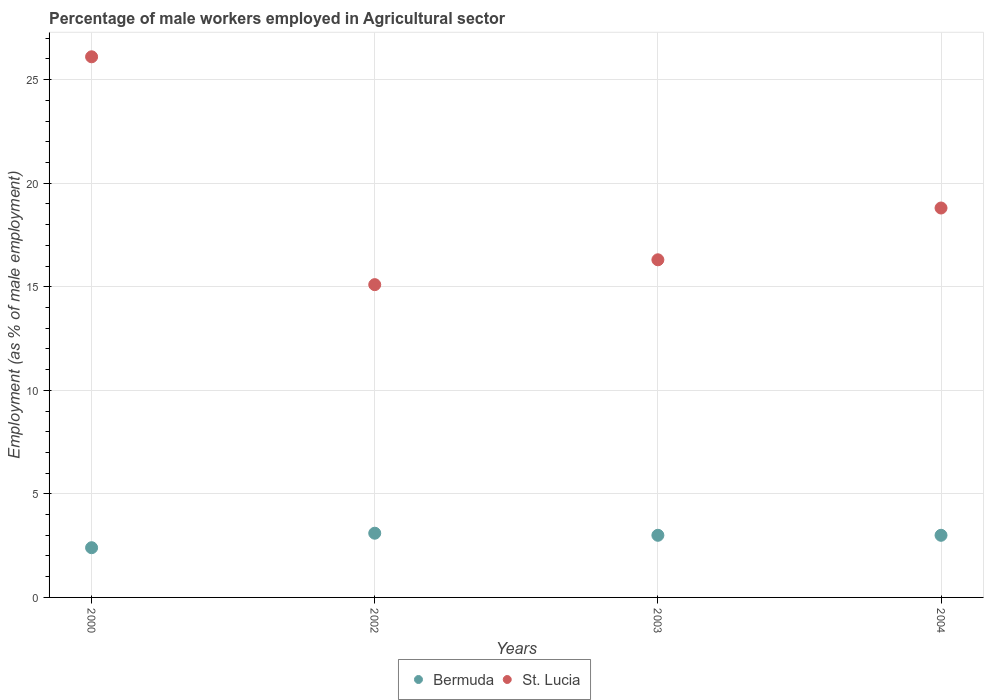How many different coloured dotlines are there?
Offer a terse response. 2. Is the number of dotlines equal to the number of legend labels?
Provide a short and direct response. Yes. What is the percentage of male workers employed in Agricultural sector in Bermuda in 2000?
Make the answer very short. 2.4. Across all years, what is the maximum percentage of male workers employed in Agricultural sector in St. Lucia?
Ensure brevity in your answer.  26.1. Across all years, what is the minimum percentage of male workers employed in Agricultural sector in Bermuda?
Your response must be concise. 2.4. What is the total percentage of male workers employed in Agricultural sector in St. Lucia in the graph?
Make the answer very short. 76.3. What is the difference between the percentage of male workers employed in Agricultural sector in Bermuda in 2000 and that in 2004?
Keep it short and to the point. -0.6. What is the difference between the percentage of male workers employed in Agricultural sector in St. Lucia in 2002 and the percentage of male workers employed in Agricultural sector in Bermuda in 2003?
Your response must be concise. 12.1. What is the average percentage of male workers employed in Agricultural sector in St. Lucia per year?
Your response must be concise. 19.07. In the year 2003, what is the difference between the percentage of male workers employed in Agricultural sector in St. Lucia and percentage of male workers employed in Agricultural sector in Bermuda?
Your answer should be very brief. 13.3. In how many years, is the percentage of male workers employed in Agricultural sector in St. Lucia greater than 13 %?
Provide a short and direct response. 4. What is the ratio of the percentage of male workers employed in Agricultural sector in St. Lucia in 2002 to that in 2004?
Provide a succinct answer. 0.8. Is the difference between the percentage of male workers employed in Agricultural sector in St. Lucia in 2002 and 2004 greater than the difference between the percentage of male workers employed in Agricultural sector in Bermuda in 2002 and 2004?
Keep it short and to the point. No. What is the difference between the highest and the second highest percentage of male workers employed in Agricultural sector in St. Lucia?
Provide a short and direct response. 7.3. What is the difference between the highest and the lowest percentage of male workers employed in Agricultural sector in St. Lucia?
Offer a very short reply. 11. In how many years, is the percentage of male workers employed in Agricultural sector in Bermuda greater than the average percentage of male workers employed in Agricultural sector in Bermuda taken over all years?
Provide a short and direct response. 3. Does the percentage of male workers employed in Agricultural sector in St. Lucia monotonically increase over the years?
Provide a short and direct response. No. Does the graph contain any zero values?
Offer a very short reply. No. Does the graph contain grids?
Your answer should be compact. Yes. Where does the legend appear in the graph?
Keep it short and to the point. Bottom center. How many legend labels are there?
Give a very brief answer. 2. What is the title of the graph?
Provide a succinct answer. Percentage of male workers employed in Agricultural sector. Does "Niger" appear as one of the legend labels in the graph?
Ensure brevity in your answer.  No. What is the label or title of the X-axis?
Ensure brevity in your answer.  Years. What is the label or title of the Y-axis?
Ensure brevity in your answer.  Employment (as % of male employment). What is the Employment (as % of male employment) of Bermuda in 2000?
Ensure brevity in your answer.  2.4. What is the Employment (as % of male employment) of St. Lucia in 2000?
Provide a succinct answer. 26.1. What is the Employment (as % of male employment) of Bermuda in 2002?
Ensure brevity in your answer.  3.1. What is the Employment (as % of male employment) of St. Lucia in 2002?
Offer a very short reply. 15.1. What is the Employment (as % of male employment) in St. Lucia in 2003?
Provide a short and direct response. 16.3. What is the Employment (as % of male employment) of St. Lucia in 2004?
Keep it short and to the point. 18.8. Across all years, what is the maximum Employment (as % of male employment) in Bermuda?
Offer a very short reply. 3.1. Across all years, what is the maximum Employment (as % of male employment) of St. Lucia?
Give a very brief answer. 26.1. Across all years, what is the minimum Employment (as % of male employment) of Bermuda?
Ensure brevity in your answer.  2.4. Across all years, what is the minimum Employment (as % of male employment) of St. Lucia?
Give a very brief answer. 15.1. What is the total Employment (as % of male employment) in Bermuda in the graph?
Ensure brevity in your answer.  11.5. What is the total Employment (as % of male employment) in St. Lucia in the graph?
Ensure brevity in your answer.  76.3. What is the difference between the Employment (as % of male employment) of St. Lucia in 2000 and that in 2002?
Offer a very short reply. 11. What is the difference between the Employment (as % of male employment) in Bermuda in 2000 and that in 2003?
Your response must be concise. -0.6. What is the difference between the Employment (as % of male employment) in Bermuda in 2000 and that in 2004?
Offer a very short reply. -0.6. What is the difference between the Employment (as % of male employment) in St. Lucia in 2002 and that in 2003?
Offer a terse response. -1.2. What is the difference between the Employment (as % of male employment) in Bermuda in 2002 and that in 2004?
Keep it short and to the point. 0.1. What is the difference between the Employment (as % of male employment) of Bermuda in 2000 and the Employment (as % of male employment) of St. Lucia in 2003?
Offer a terse response. -13.9. What is the difference between the Employment (as % of male employment) in Bermuda in 2000 and the Employment (as % of male employment) in St. Lucia in 2004?
Provide a short and direct response. -16.4. What is the difference between the Employment (as % of male employment) of Bermuda in 2002 and the Employment (as % of male employment) of St. Lucia in 2003?
Provide a succinct answer. -13.2. What is the difference between the Employment (as % of male employment) of Bermuda in 2002 and the Employment (as % of male employment) of St. Lucia in 2004?
Provide a short and direct response. -15.7. What is the difference between the Employment (as % of male employment) of Bermuda in 2003 and the Employment (as % of male employment) of St. Lucia in 2004?
Provide a succinct answer. -15.8. What is the average Employment (as % of male employment) in Bermuda per year?
Offer a very short reply. 2.88. What is the average Employment (as % of male employment) of St. Lucia per year?
Make the answer very short. 19.07. In the year 2000, what is the difference between the Employment (as % of male employment) of Bermuda and Employment (as % of male employment) of St. Lucia?
Keep it short and to the point. -23.7. In the year 2002, what is the difference between the Employment (as % of male employment) of Bermuda and Employment (as % of male employment) of St. Lucia?
Your answer should be very brief. -12. In the year 2004, what is the difference between the Employment (as % of male employment) in Bermuda and Employment (as % of male employment) in St. Lucia?
Offer a very short reply. -15.8. What is the ratio of the Employment (as % of male employment) in Bermuda in 2000 to that in 2002?
Provide a short and direct response. 0.77. What is the ratio of the Employment (as % of male employment) of St. Lucia in 2000 to that in 2002?
Offer a very short reply. 1.73. What is the ratio of the Employment (as % of male employment) in St. Lucia in 2000 to that in 2003?
Your answer should be very brief. 1.6. What is the ratio of the Employment (as % of male employment) of St. Lucia in 2000 to that in 2004?
Your answer should be very brief. 1.39. What is the ratio of the Employment (as % of male employment) of St. Lucia in 2002 to that in 2003?
Your answer should be compact. 0.93. What is the ratio of the Employment (as % of male employment) of St. Lucia in 2002 to that in 2004?
Provide a short and direct response. 0.8. What is the ratio of the Employment (as % of male employment) of Bermuda in 2003 to that in 2004?
Your answer should be very brief. 1. What is the ratio of the Employment (as % of male employment) of St. Lucia in 2003 to that in 2004?
Your answer should be very brief. 0.87. What is the difference between the highest and the second highest Employment (as % of male employment) of St. Lucia?
Your response must be concise. 7.3. 